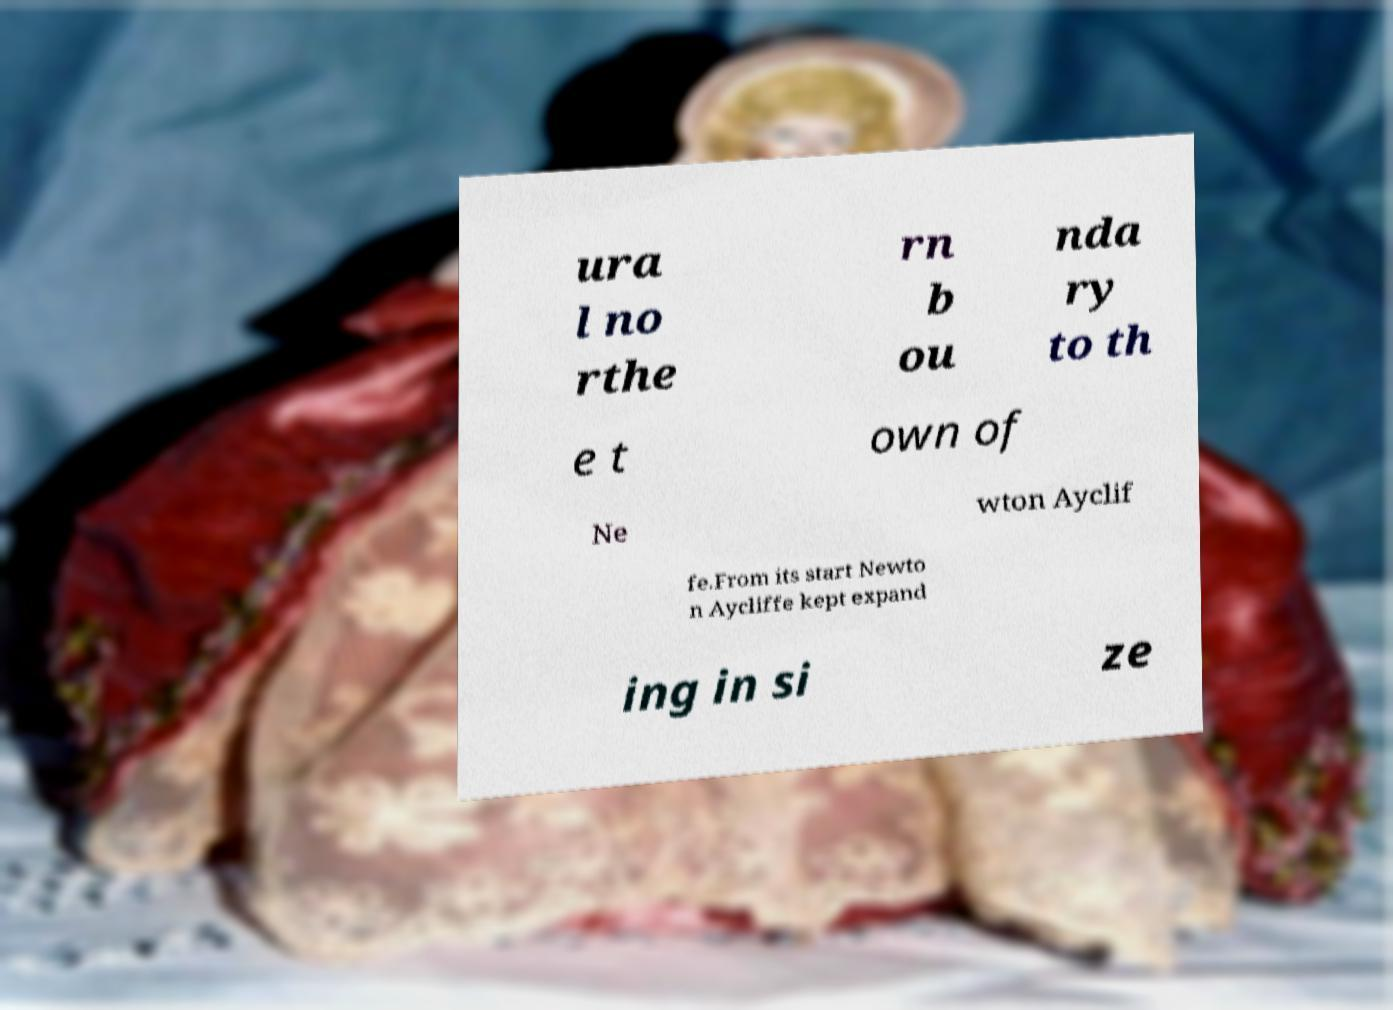Can you accurately transcribe the text from the provided image for me? ura l no rthe rn b ou nda ry to th e t own of Ne wton Ayclif fe.From its start Newto n Aycliffe kept expand ing in si ze 